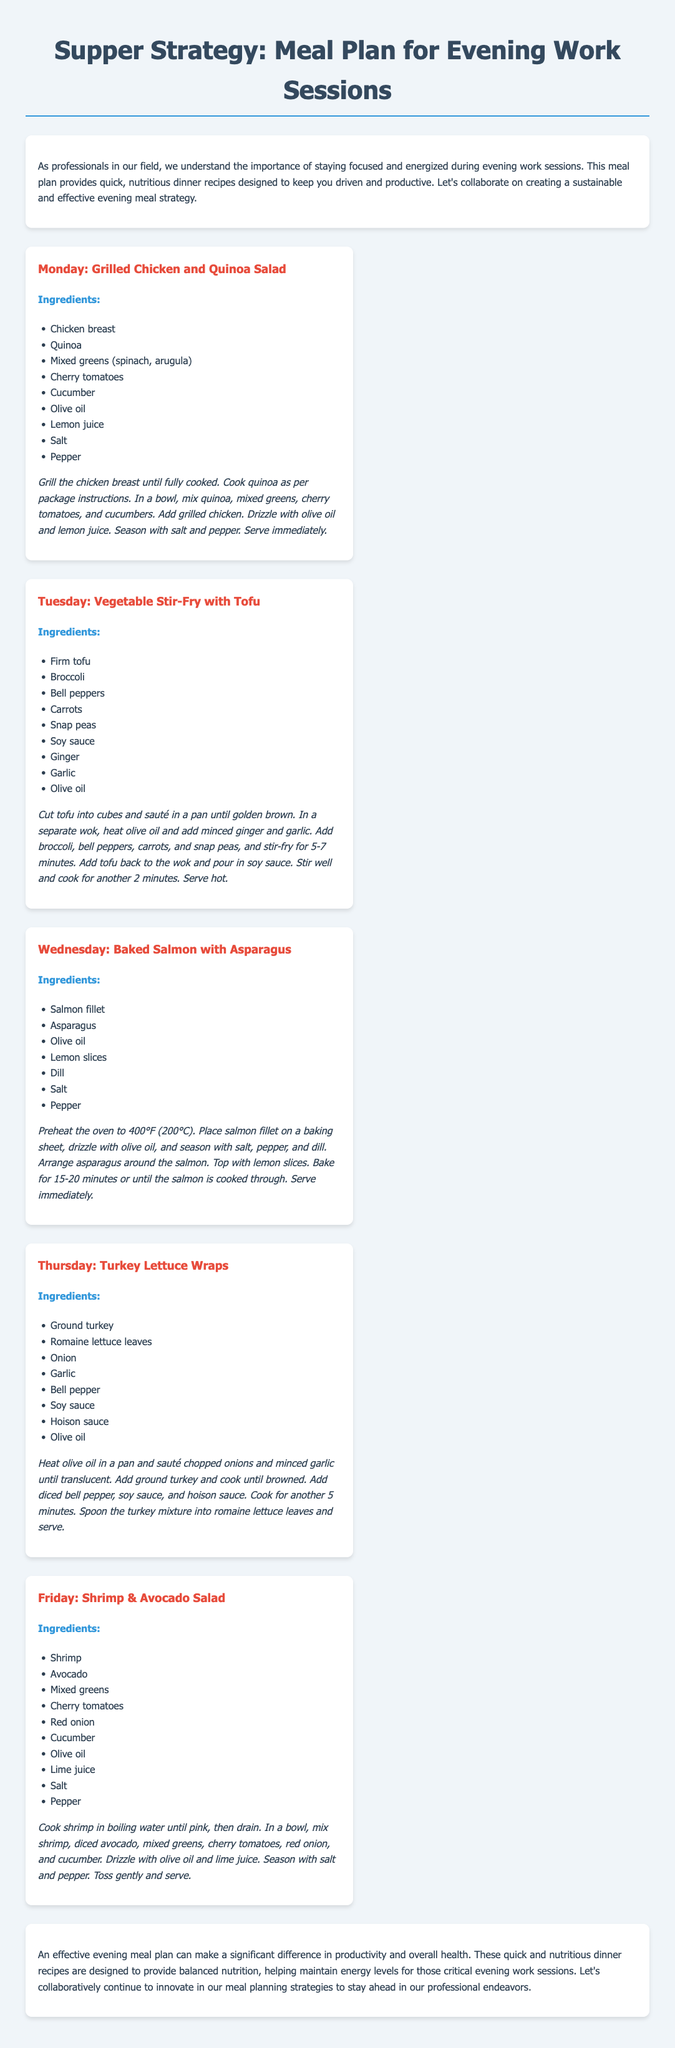What is the focus of the meal plan? The meal plan focuses on providing quick and nutritious dinner recipes for evening work sessions.
Answer: Quick and nutritious dinner recipes How many meals are included in the plan? The document lists five meals for the week from Monday to Friday.
Answer: Five meals What ingredient is used in the recipe for Tuesday? The main ingredient mentioned in the Tuesday meal recipe is firm tofu.
Answer: Firm tofu Which day features a baked fish dish? The meal for Wednesday is a baked fish dish, specifically baked salmon.
Answer: Wednesday What cooking method is used for the chicken in the Monday recipe? The chicken in the Monday recipe is grilled until fully cooked.
Answer: Grilled What is the main vegetable in the Thursday meal? Romaine lettuce is the main vegetable used in the Thursday meal.
Answer: Romaine lettuce What two sauces are included in the turkey lettuce wraps? The sauces mentioned in the turkey lettuce wraps are soy sauce and hoisin sauce.
Answer: Soy sauce and hoisin sauce What type of salad is served on Friday? The Friday meal is a shrimp and avocado salad.
Answer: Shrimp and avocado salad What temperature should the oven be preheated to for the Wednesday meal? The oven should be preheated to 400°F (200°C) for the Wednesday meal.
Answer: 400°F (200°C) 